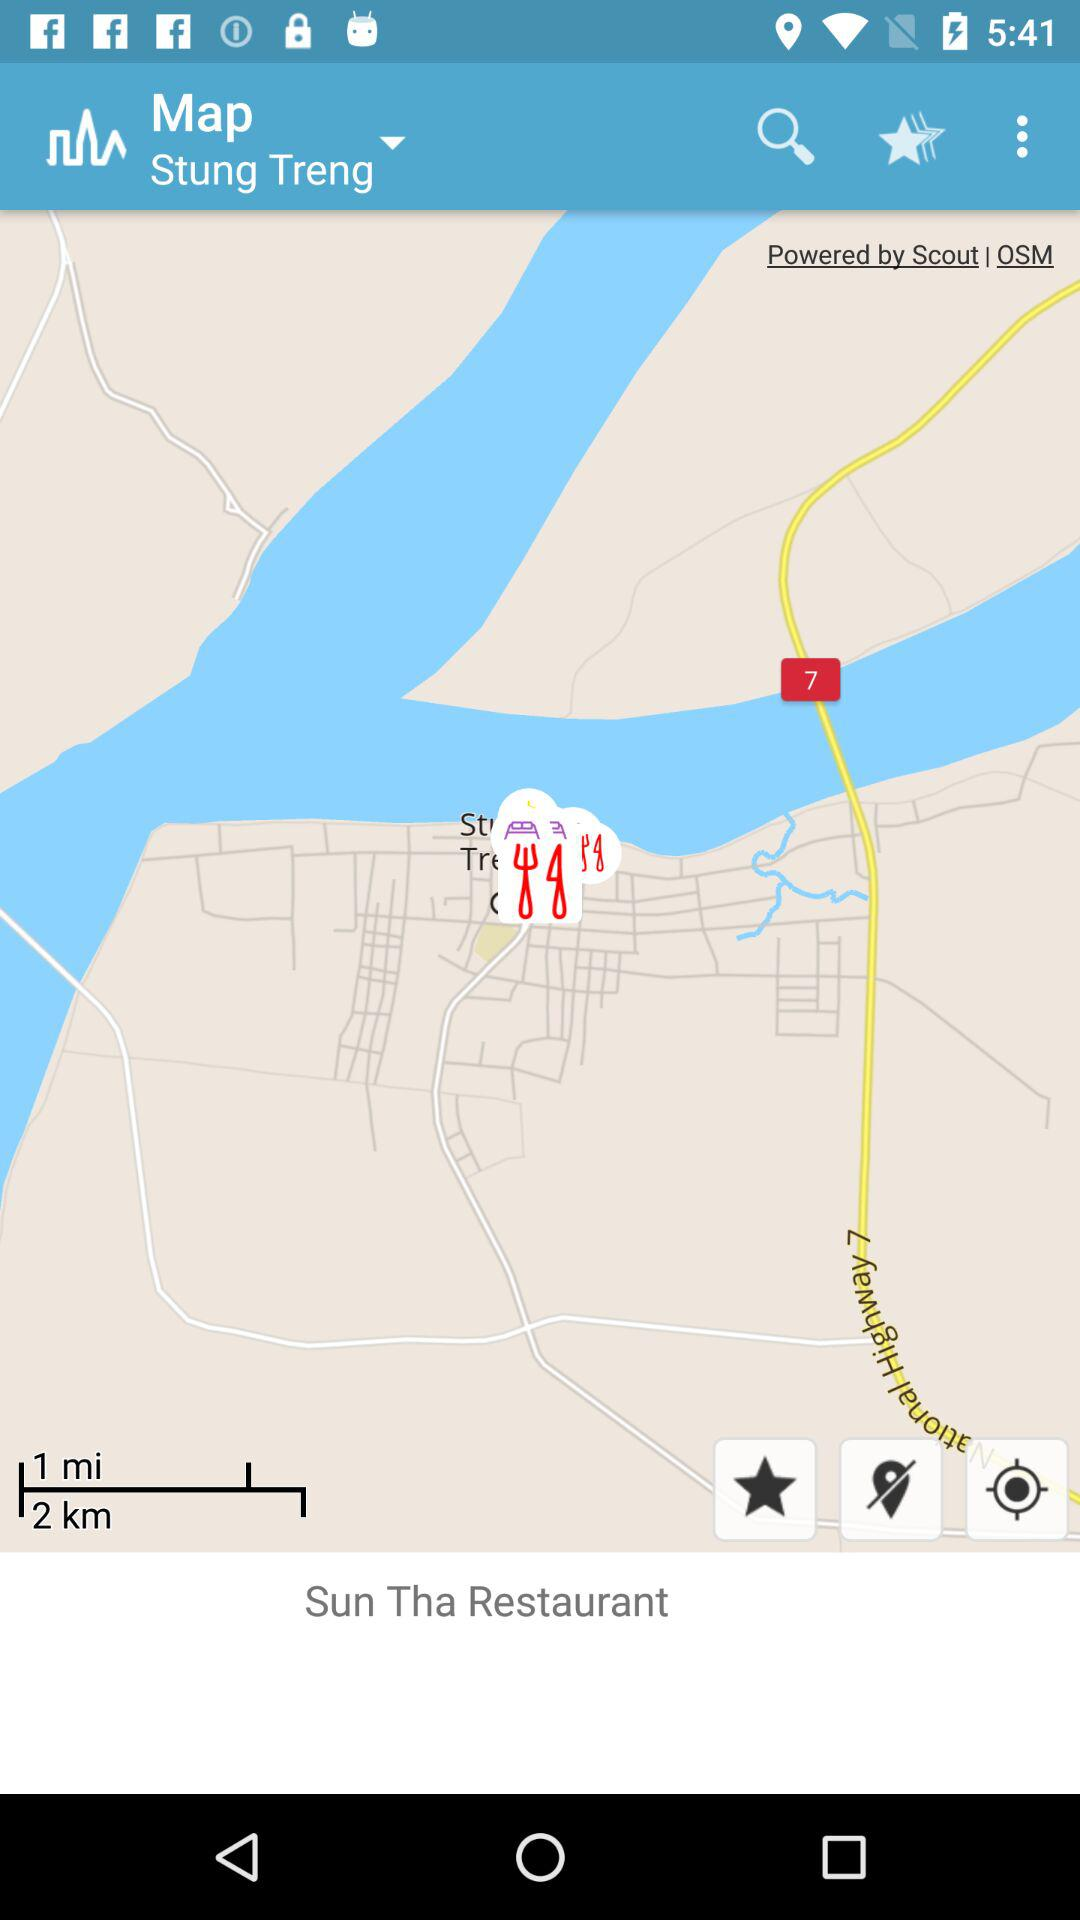What is the name of the restaurant? The name of the restaurant is "Sun Tha Restaurant". 